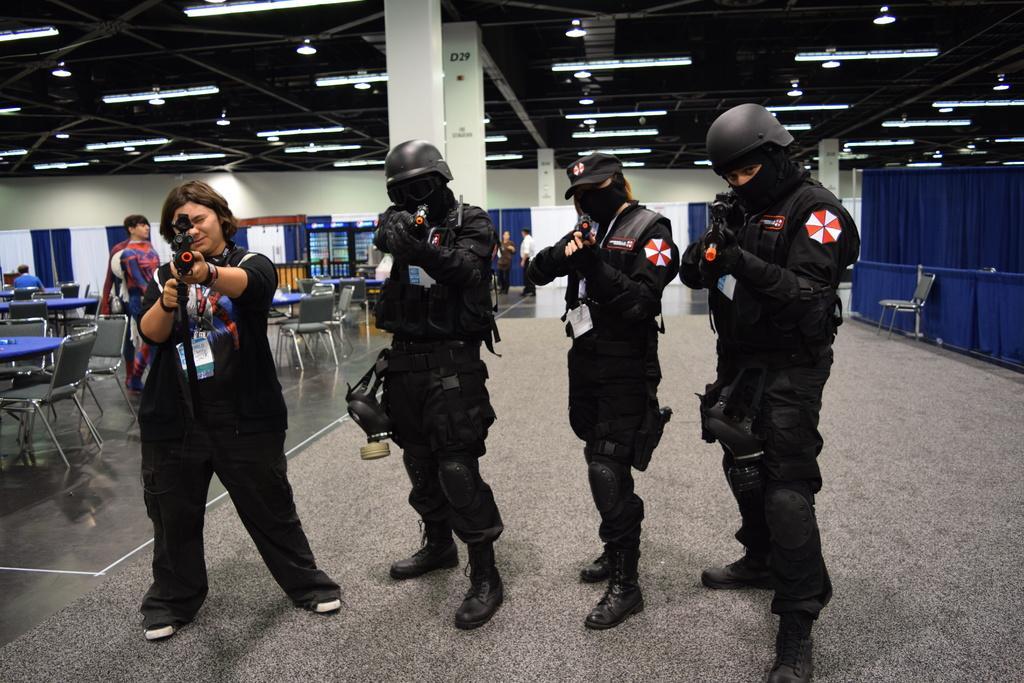Could you give a brief overview of what you see in this image? In this picture there are people in the center of the image, by holding guns in there hands and there are tables and chairs in the background area of the image, there are other people and curtains in the image, there are lamps on the roof at the top side of the image. 